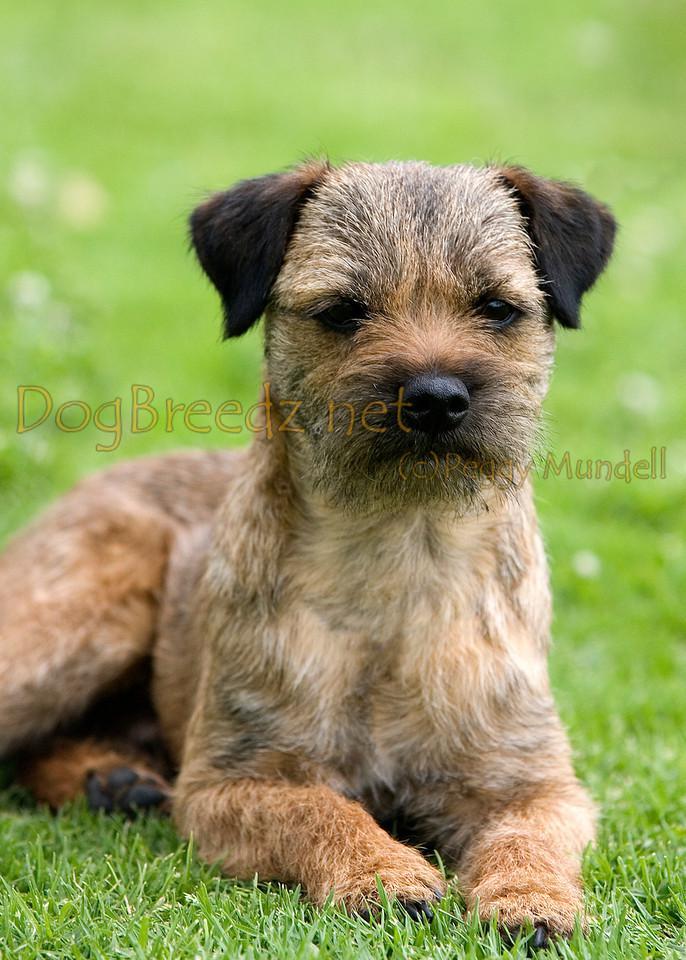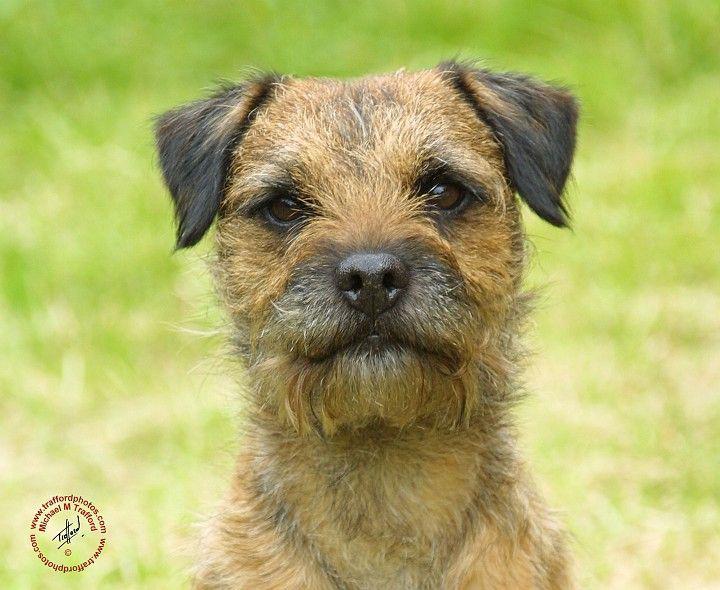The first image is the image on the left, the second image is the image on the right. Analyze the images presented: Is the assertion "A dog is looking directly at the camera in both images." valid? Answer yes or no. Yes. 